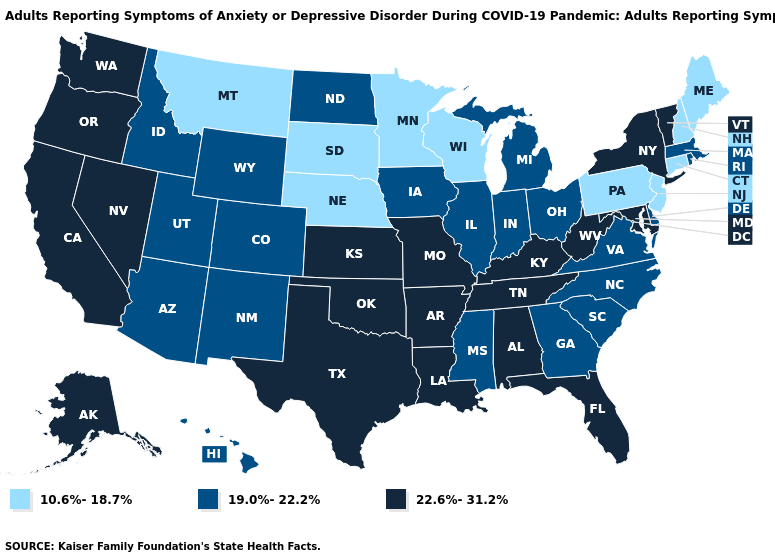Among the states that border Illinois , does Kentucky have the highest value?
Keep it brief. Yes. Among the states that border Oregon , which have the lowest value?
Concise answer only. Idaho. Does Rhode Island have a lower value than Arkansas?
Keep it brief. Yes. Is the legend a continuous bar?
Short answer required. No. Name the states that have a value in the range 10.6%-18.7%?
Write a very short answer. Connecticut, Maine, Minnesota, Montana, Nebraska, New Hampshire, New Jersey, Pennsylvania, South Dakota, Wisconsin. Does the map have missing data?
Give a very brief answer. No. What is the value of Indiana?
Be succinct. 19.0%-22.2%. Among the states that border Arkansas , does Oklahoma have the highest value?
Write a very short answer. Yes. What is the highest value in the South ?
Keep it brief. 22.6%-31.2%. Name the states that have a value in the range 22.6%-31.2%?
Write a very short answer. Alabama, Alaska, Arkansas, California, Florida, Kansas, Kentucky, Louisiana, Maryland, Missouri, Nevada, New York, Oklahoma, Oregon, Tennessee, Texas, Vermont, Washington, West Virginia. What is the lowest value in the MidWest?
Give a very brief answer. 10.6%-18.7%. What is the value of North Carolina?
Be succinct. 19.0%-22.2%. Does Iowa have the same value as Illinois?
Concise answer only. Yes. What is the value of Louisiana?
Be succinct. 22.6%-31.2%. 